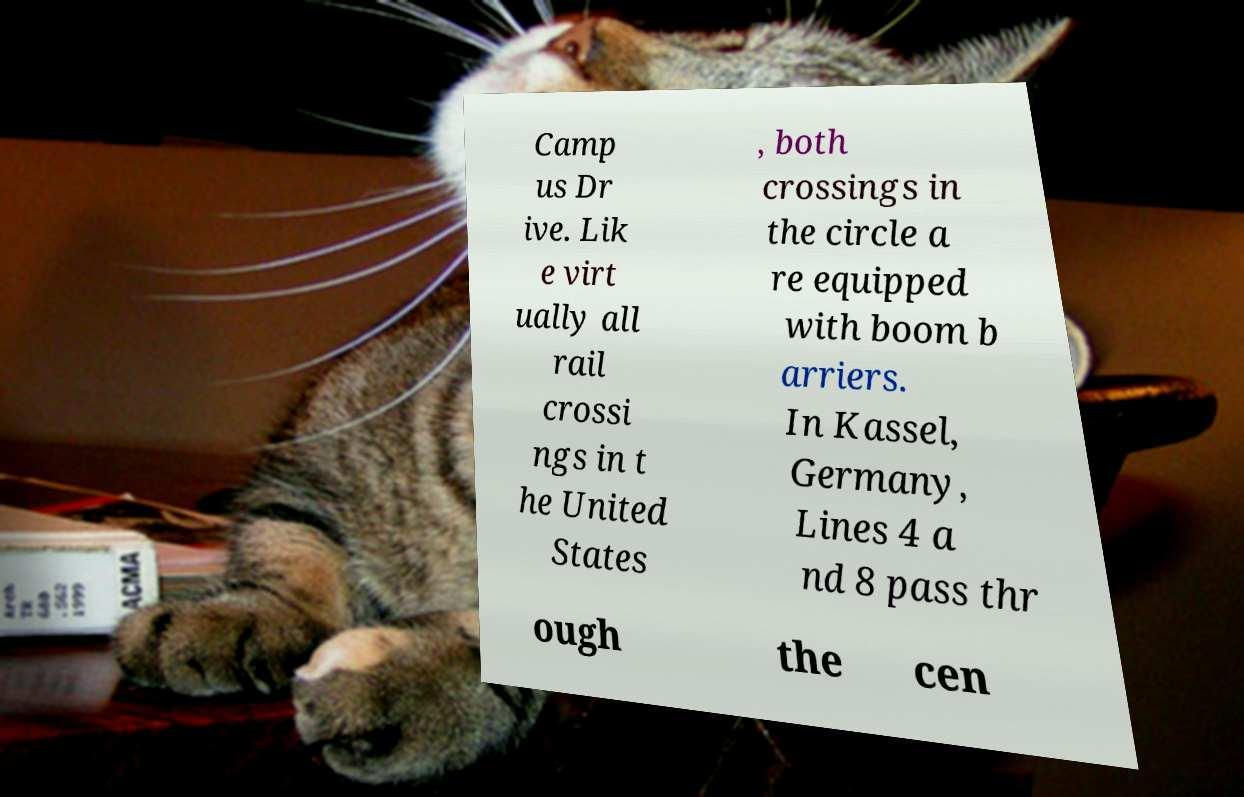For documentation purposes, I need the text within this image transcribed. Could you provide that? Camp us Dr ive. Lik e virt ually all rail crossi ngs in t he United States , both crossings in the circle a re equipped with boom b arriers. In Kassel, Germany, Lines 4 a nd 8 pass thr ough the cen 